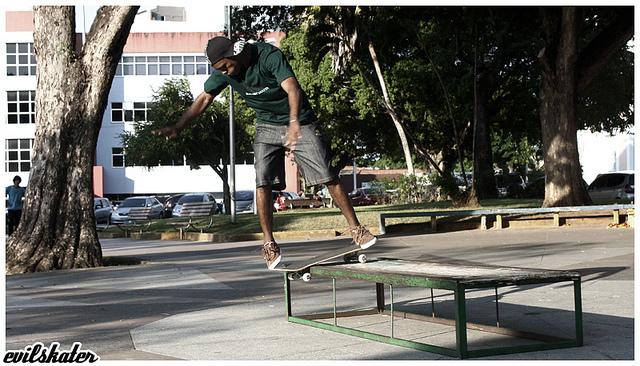What is he riding?
Be succinct. Skateboard. Is this a skate park?
Be succinct. Yes. Is he in the air?
Give a very brief answer. No. 